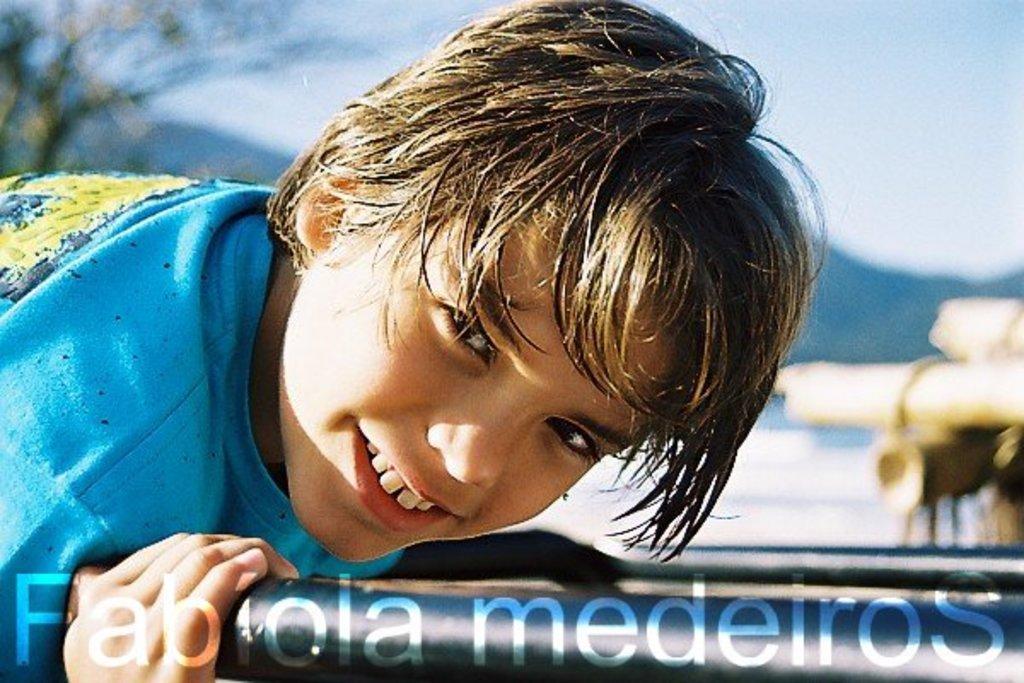Could you give a brief overview of what you see in this image? We can see a boy is holding an object. In the background there is a tree on the left side, mountains, objects on the right side and sky. 